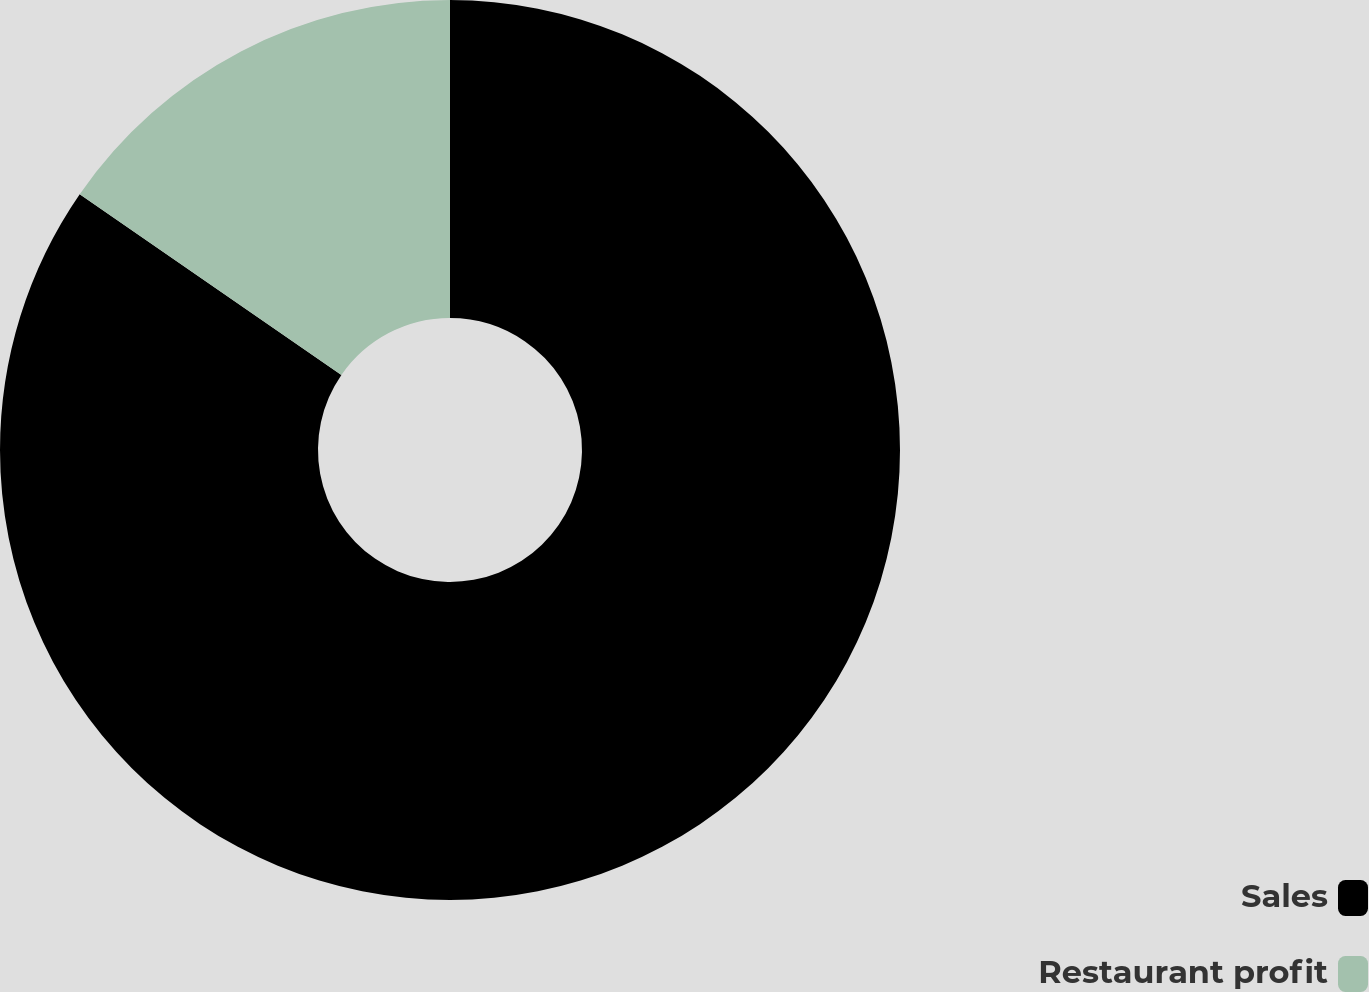Convert chart. <chart><loc_0><loc_0><loc_500><loc_500><pie_chart><fcel>Sales<fcel>Restaurant profit<nl><fcel>84.62%<fcel>15.38%<nl></chart> 